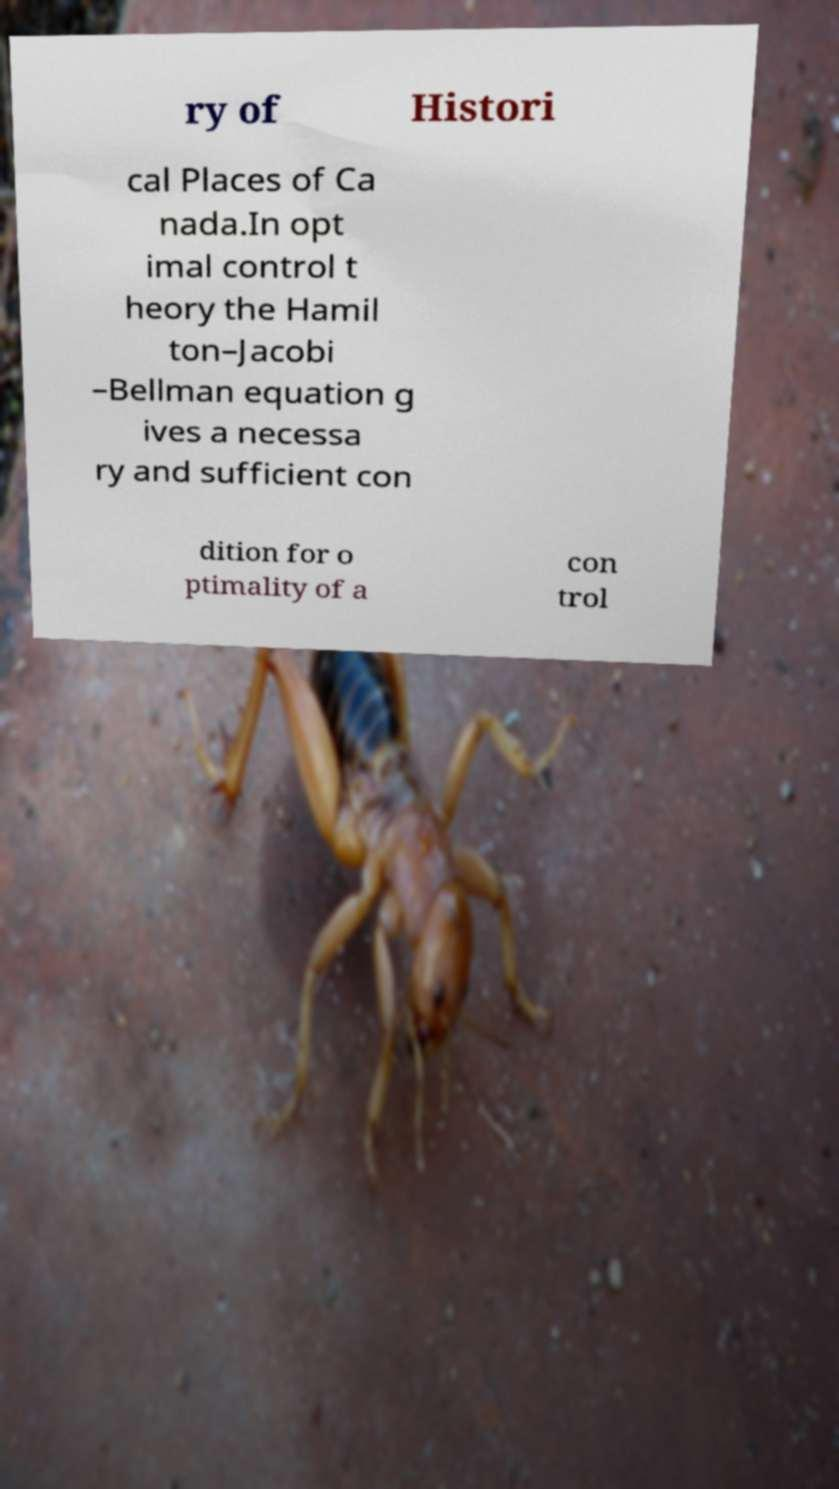Please identify and transcribe the text found in this image. ry of Histori cal Places of Ca nada.In opt imal control t heory the Hamil ton–Jacobi –Bellman equation g ives a necessa ry and sufficient con dition for o ptimality of a con trol 